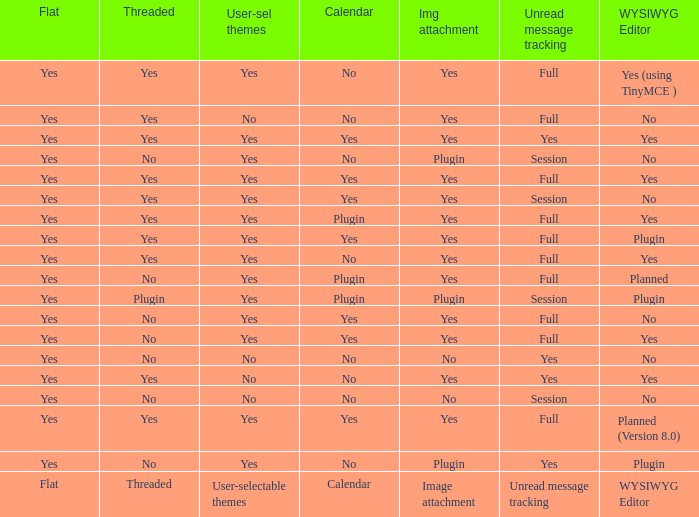Which Calendar has WYSIWYG Editor of yes and an Unread message tracking of yes? Yes, No. 